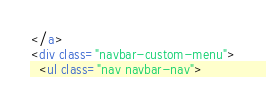Convert code to text. <code><loc_0><loc_0><loc_500><loc_500><_HTML_></a>
<div class="navbar-custom-menu">
  <ul class="nav navbar-nav"></code> 